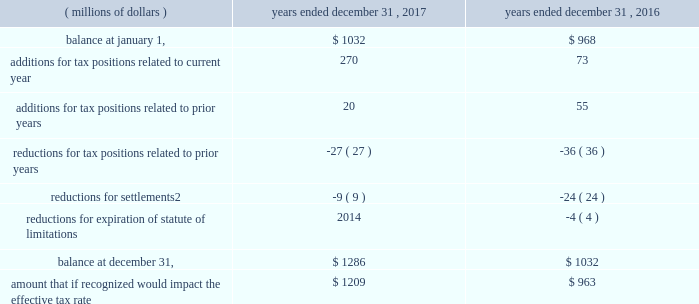82 | 2017 form 10-k a reconciliation of the beginning and ending amount of gross unrecognized tax benefits for uncertain tax positions , including positions impacting only the timing of tax benefits , follows .
Reconciliation of unrecognized tax benefits:1 years a0ended a0december a031 .
1 foreign currency impacts are included within each line as applicable .
2 includes cash payment or other reduction of assets to settle liability .
We classify interest and penalties on income taxes as a component of the provision for income taxes .
We recognized a net provision for interest and penalties of $ 38 million , $ 34 million and $ 20 million during the years ended december 31 , 2017 , 2016 and 2015 , respectively .
The total amount of interest and penalties accrued was $ 157 million and $ 120 million as of december a031 , 2017 and 2016 , respectively .
On january 31 , 2018 , we received a revenue agent 2019s report from the irs indicating the end of the field examination of our u.s .
Income tax returns for 2010 to 2012 .
In the audits of 2007 to 2012 including the impact of a loss carryback to 2005 , the irs has proposed to tax in the united states profits earned from certain parts transactions by csarl , based on the irs examination team 2019s application of the 201csubstance-over-form 201d or 201cassignment-of-income 201d judicial doctrines .
We are vigorously contesting the proposed increases to tax and penalties for these years of approximately $ 2.3 billion .
We believe that the relevant transactions complied with applicable tax laws and did not violate judicial doctrines .
We have filed u.s .
Income tax returns on this same basis for years after 2012 .
Based on the information currently available , we do not anticipate a significant increase or decrease to our unrecognized tax benefits for this matter within the next 12 months .
We currently believe the ultimate disposition of this matter will not have a material adverse effect on our consolidated financial position , liquidity or results of operations .
With the exception of a loss carryback to 2005 , tax years prior to 2007 are generally no longer subject to u.s .
Tax assessment .
In our major non-u.s .
Jurisdictions including australia , brazil , china , germany , japan , mexico , switzerland , singapore and the u.k. , tax years are typically subject to examination for three to ten years .
Due to the uncertainty related to the timing and potential outcome of audits , we cannot estimate the range of reasonably possible change in unrecognized tax benefits in the next 12 months. .
What is the percentage change net provision for interest and penalties from 2016 to 2017? 
Computations: ((38 - 34) / 34)
Answer: 0.11765. 